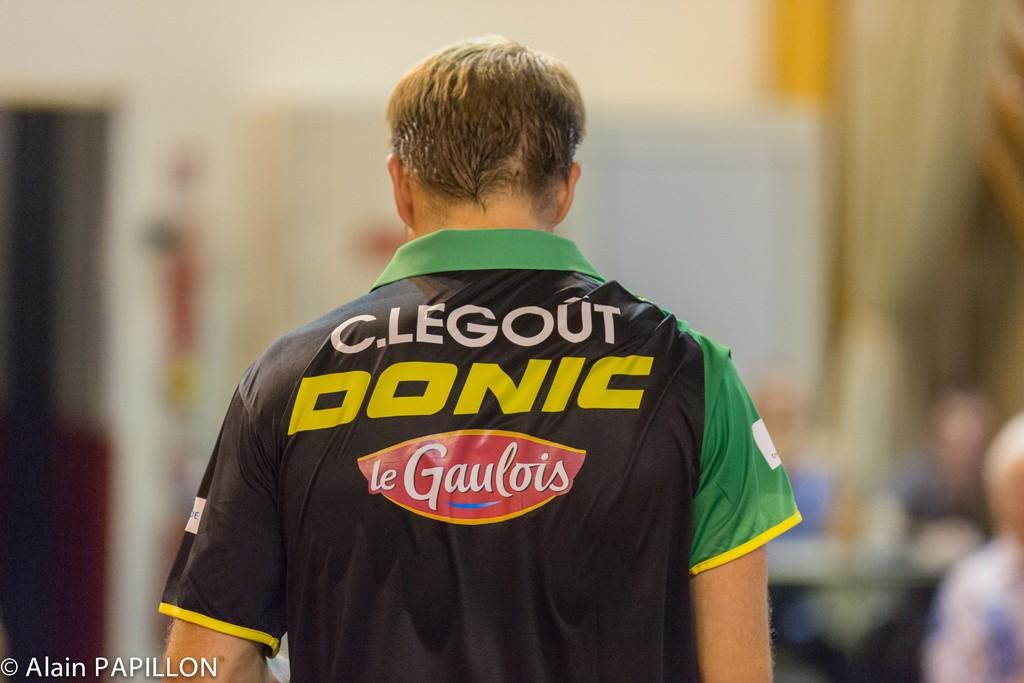Provide a one-sentence caption for the provided image. The back of a man with short brown hair whose shirt says C.Legout Donic le Gaulois. 